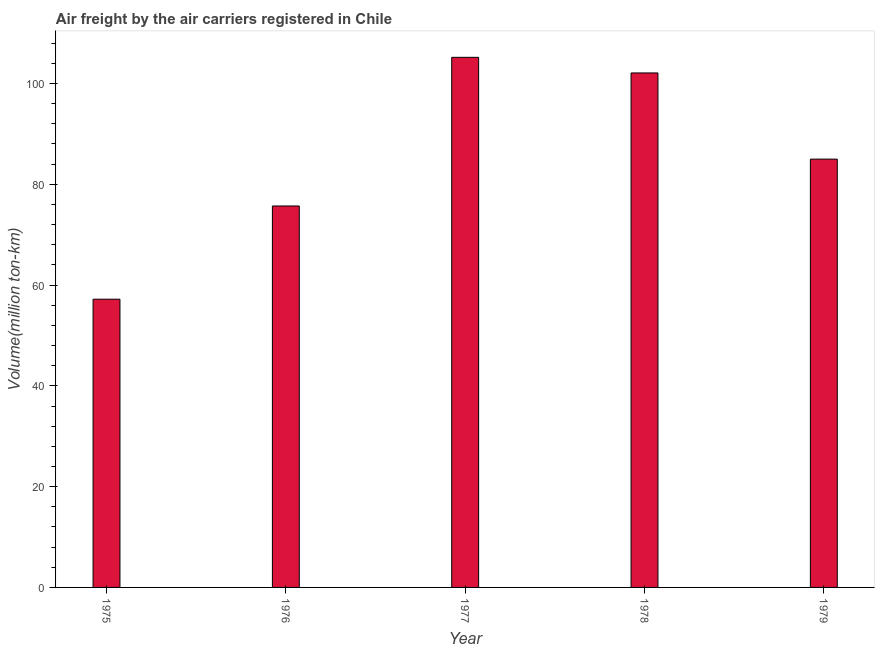Does the graph contain any zero values?
Offer a very short reply. No. Does the graph contain grids?
Provide a succinct answer. No. What is the title of the graph?
Offer a very short reply. Air freight by the air carriers registered in Chile. What is the label or title of the X-axis?
Your answer should be compact. Year. What is the label or title of the Y-axis?
Your answer should be compact. Volume(million ton-km). What is the air freight in 1975?
Offer a terse response. 57.2. Across all years, what is the maximum air freight?
Keep it short and to the point. 105.2. Across all years, what is the minimum air freight?
Keep it short and to the point. 57.2. In which year was the air freight minimum?
Offer a terse response. 1975. What is the sum of the air freight?
Your answer should be very brief. 425.2. What is the difference between the air freight in 1975 and 1976?
Provide a short and direct response. -18.5. What is the average air freight per year?
Offer a terse response. 85.04. What is the median air freight?
Offer a very short reply. 85. Do a majority of the years between 1977 and 1978 (inclusive) have air freight greater than 76 million ton-km?
Offer a terse response. Yes. What is the ratio of the air freight in 1977 to that in 1979?
Your answer should be very brief. 1.24. Is the difference between the air freight in 1977 and 1979 greater than the difference between any two years?
Offer a very short reply. No. Is the sum of the air freight in 1975 and 1976 greater than the maximum air freight across all years?
Make the answer very short. Yes. Are all the bars in the graph horizontal?
Offer a very short reply. No. What is the difference between two consecutive major ticks on the Y-axis?
Give a very brief answer. 20. What is the Volume(million ton-km) in 1975?
Provide a succinct answer. 57.2. What is the Volume(million ton-km) of 1976?
Keep it short and to the point. 75.7. What is the Volume(million ton-km) in 1977?
Provide a succinct answer. 105.2. What is the Volume(million ton-km) of 1978?
Offer a very short reply. 102.1. What is the Volume(million ton-km) of 1979?
Your response must be concise. 85. What is the difference between the Volume(million ton-km) in 1975 and 1976?
Keep it short and to the point. -18.5. What is the difference between the Volume(million ton-km) in 1975 and 1977?
Keep it short and to the point. -48. What is the difference between the Volume(million ton-km) in 1975 and 1978?
Offer a terse response. -44.9. What is the difference between the Volume(million ton-km) in 1975 and 1979?
Provide a succinct answer. -27.8. What is the difference between the Volume(million ton-km) in 1976 and 1977?
Provide a succinct answer. -29.5. What is the difference between the Volume(million ton-km) in 1976 and 1978?
Make the answer very short. -26.4. What is the difference between the Volume(million ton-km) in 1977 and 1978?
Provide a short and direct response. 3.1. What is the difference between the Volume(million ton-km) in 1977 and 1979?
Your answer should be very brief. 20.2. What is the ratio of the Volume(million ton-km) in 1975 to that in 1976?
Make the answer very short. 0.76. What is the ratio of the Volume(million ton-km) in 1975 to that in 1977?
Ensure brevity in your answer.  0.54. What is the ratio of the Volume(million ton-km) in 1975 to that in 1978?
Provide a short and direct response. 0.56. What is the ratio of the Volume(million ton-km) in 1975 to that in 1979?
Your answer should be compact. 0.67. What is the ratio of the Volume(million ton-km) in 1976 to that in 1977?
Keep it short and to the point. 0.72. What is the ratio of the Volume(million ton-km) in 1976 to that in 1978?
Offer a terse response. 0.74. What is the ratio of the Volume(million ton-km) in 1976 to that in 1979?
Offer a very short reply. 0.89. What is the ratio of the Volume(million ton-km) in 1977 to that in 1979?
Offer a very short reply. 1.24. What is the ratio of the Volume(million ton-km) in 1978 to that in 1979?
Your response must be concise. 1.2. 